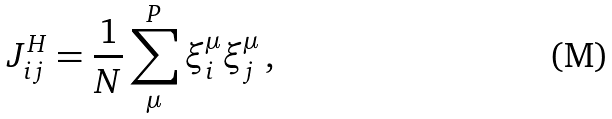Convert formula to latex. <formula><loc_0><loc_0><loc_500><loc_500>J _ { i j } ^ { H } = \frac { 1 } { N } \sum _ { \mu } ^ { P } \xi _ { i } ^ { \mu } \xi _ { j } ^ { \mu } \, ,</formula> 